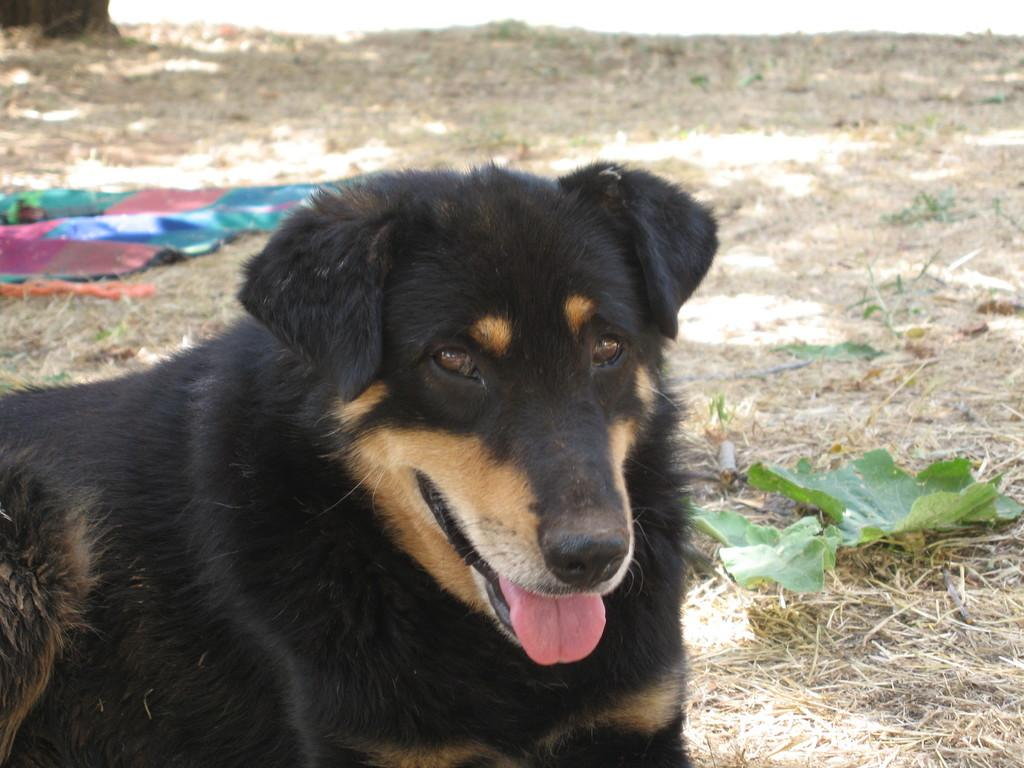What is on the ground in the image? There are objects on the ground in the image. What type of vegetation can be seen in the image? There are green leaves in the image. What is the texture of the grass in the image? Dried grass is present in the image. What type of animal is in the image? There is a dog in the image. What type of collar is the monkey wearing in the image? There is no monkey present in the image, and therefore no collar can be observed. Is there any ice visible in the image? There is no ice present in the image. 